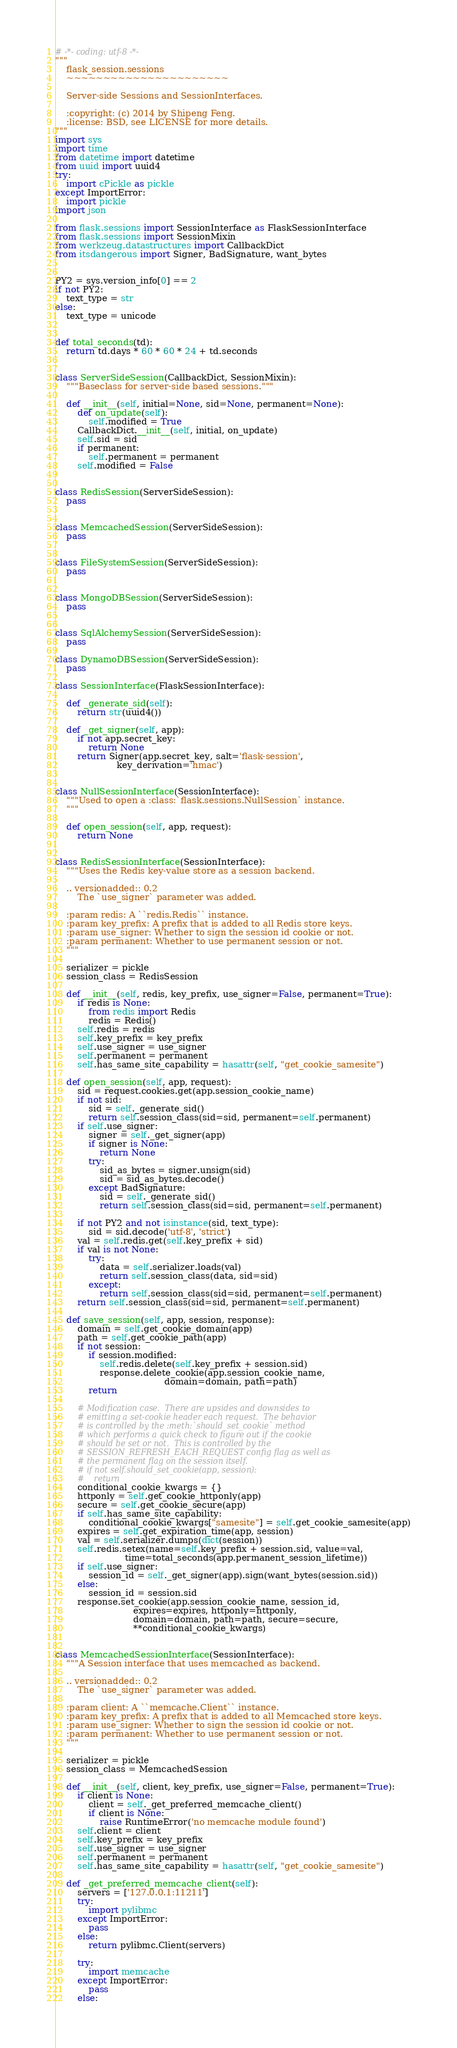<code> <loc_0><loc_0><loc_500><loc_500><_Python_># -*- coding: utf-8 -*-
"""
    flask_session.sessions
    ~~~~~~~~~~~~~~~~~~~~~~

    Server-side Sessions and SessionInterfaces.

    :copyright: (c) 2014 by Shipeng Feng.
    :license: BSD, see LICENSE for more details.
"""
import sys
import time
from datetime import datetime
from uuid import uuid4
try:
    import cPickle as pickle
except ImportError:
    import pickle
import json

from flask.sessions import SessionInterface as FlaskSessionInterface
from flask.sessions import SessionMixin
from werkzeug.datastructures import CallbackDict
from itsdangerous import Signer, BadSignature, want_bytes


PY2 = sys.version_info[0] == 2
if not PY2:
    text_type = str
else:
    text_type = unicode


def total_seconds(td):
    return td.days * 60 * 60 * 24 + td.seconds


class ServerSideSession(CallbackDict, SessionMixin):
    """Baseclass for server-side based sessions."""

    def __init__(self, initial=None, sid=None, permanent=None):
        def on_update(self):
            self.modified = True
        CallbackDict.__init__(self, initial, on_update)
        self.sid = sid
        if permanent:
            self.permanent = permanent
        self.modified = False


class RedisSession(ServerSideSession):
    pass


class MemcachedSession(ServerSideSession):
    pass


class FileSystemSession(ServerSideSession):
    pass


class MongoDBSession(ServerSideSession):
    pass


class SqlAlchemySession(ServerSideSession):
    pass

class DynamoDBSession(ServerSideSession):
    pass

class SessionInterface(FlaskSessionInterface):

    def _generate_sid(self):
        return str(uuid4())

    def _get_signer(self, app):
        if not app.secret_key:
            return None
        return Signer(app.secret_key, salt='flask-session',
                      key_derivation='hmac')


class NullSessionInterface(SessionInterface):
    """Used to open a :class:`flask.sessions.NullSession` instance.
    """

    def open_session(self, app, request):
        return None


class RedisSessionInterface(SessionInterface):
    """Uses the Redis key-value store as a session backend.

    .. versionadded:: 0.2
        The `use_signer` parameter was added.

    :param redis: A ``redis.Redis`` instance.
    :param key_prefix: A prefix that is added to all Redis store keys.
    :param use_signer: Whether to sign the session id cookie or not.
    :param permanent: Whether to use permanent session or not.
    """

    serializer = pickle
    session_class = RedisSession

    def __init__(self, redis, key_prefix, use_signer=False, permanent=True):
        if redis is None:
            from redis import Redis
            redis = Redis()
        self.redis = redis
        self.key_prefix = key_prefix
        self.use_signer = use_signer
        self.permanent = permanent
        self.has_same_site_capability = hasattr(self, "get_cookie_samesite")

    def open_session(self, app, request):
        sid = request.cookies.get(app.session_cookie_name)
        if not sid:
            sid = self._generate_sid()
            return self.session_class(sid=sid, permanent=self.permanent)
        if self.use_signer:
            signer = self._get_signer(app)
            if signer is None:
                return None
            try:
                sid_as_bytes = signer.unsign(sid)
                sid = sid_as_bytes.decode()
            except BadSignature:
                sid = self._generate_sid()
                return self.session_class(sid=sid, permanent=self.permanent)

        if not PY2 and not isinstance(sid, text_type):
            sid = sid.decode('utf-8', 'strict')
        val = self.redis.get(self.key_prefix + sid)
        if val is not None:
            try:
                data = self.serializer.loads(val)
                return self.session_class(data, sid=sid)
            except:
                return self.session_class(sid=sid, permanent=self.permanent)
        return self.session_class(sid=sid, permanent=self.permanent)

    def save_session(self, app, session, response):
        domain = self.get_cookie_domain(app)
        path = self.get_cookie_path(app)
        if not session:
            if session.modified:
                self.redis.delete(self.key_prefix + session.sid)
                response.delete_cookie(app.session_cookie_name,
                                       domain=domain, path=path)
            return

        # Modification case.  There are upsides and downsides to
        # emitting a set-cookie header each request.  The behavior
        # is controlled by the :meth:`should_set_cookie` method
        # which performs a quick check to figure out if the cookie
        # should be set or not.  This is controlled by the
        # SESSION_REFRESH_EACH_REQUEST config flag as well as
        # the permanent flag on the session itself.
        # if not self.should_set_cookie(app, session):
        #    return
        conditional_cookie_kwargs = {}
        httponly = self.get_cookie_httponly(app)
        secure = self.get_cookie_secure(app)
        if self.has_same_site_capability:
            conditional_cookie_kwargs["samesite"] = self.get_cookie_samesite(app)
        expires = self.get_expiration_time(app, session)
        val = self.serializer.dumps(dict(session))
        self.redis.setex(name=self.key_prefix + session.sid, value=val,
                         time=total_seconds(app.permanent_session_lifetime))
        if self.use_signer:
            session_id = self._get_signer(app).sign(want_bytes(session.sid))
        else:
            session_id = session.sid
        response.set_cookie(app.session_cookie_name, session_id,
                            expires=expires, httponly=httponly,
                            domain=domain, path=path, secure=secure,
                            **conditional_cookie_kwargs)


class MemcachedSessionInterface(SessionInterface):
    """A Session interface that uses memcached as backend.

    .. versionadded:: 0.2
        The `use_signer` parameter was added.

    :param client: A ``memcache.Client`` instance.
    :param key_prefix: A prefix that is added to all Memcached store keys.
    :param use_signer: Whether to sign the session id cookie or not.
    :param permanent: Whether to use permanent session or not.
    """

    serializer = pickle
    session_class = MemcachedSession

    def __init__(self, client, key_prefix, use_signer=False, permanent=True):
        if client is None:
            client = self._get_preferred_memcache_client()
            if client is None:
                raise RuntimeError('no memcache module found')
        self.client = client
        self.key_prefix = key_prefix
        self.use_signer = use_signer
        self.permanent = permanent
        self.has_same_site_capability = hasattr(self, "get_cookie_samesite")

    def _get_preferred_memcache_client(self):
        servers = ['127.0.0.1:11211']
        try:
            import pylibmc
        except ImportError:
            pass
        else:
            return pylibmc.Client(servers)

        try:
            import memcache
        except ImportError:
            pass
        else:</code> 